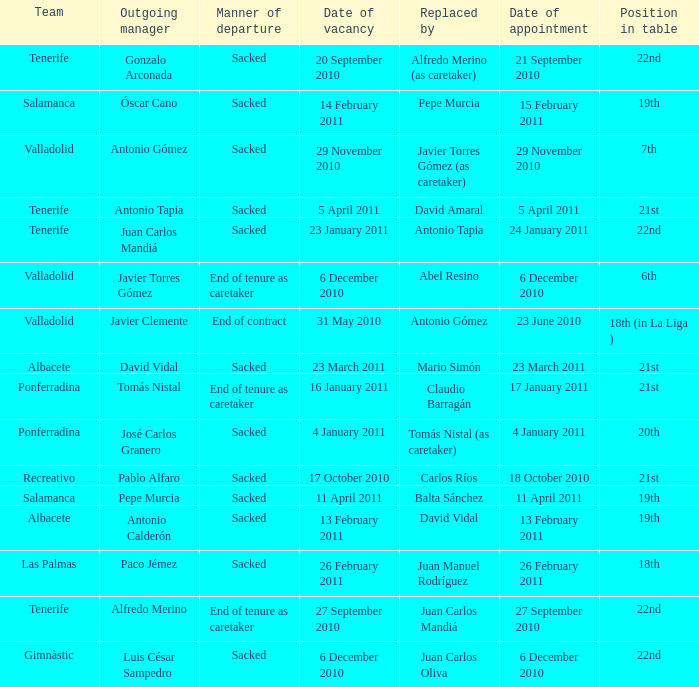What was the position of appointment date 17 january 2011 21st. 